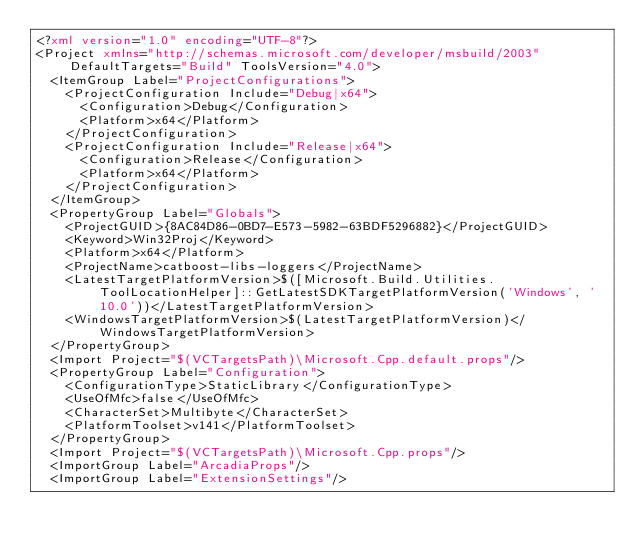Convert code to text. <code><loc_0><loc_0><loc_500><loc_500><_XML_><?xml version="1.0" encoding="UTF-8"?>
<Project xmlns="http://schemas.microsoft.com/developer/msbuild/2003" DefaultTargets="Build" ToolsVersion="4.0">
  <ItemGroup Label="ProjectConfigurations">
    <ProjectConfiguration Include="Debug|x64">
      <Configuration>Debug</Configuration>
      <Platform>x64</Platform>
    </ProjectConfiguration>
    <ProjectConfiguration Include="Release|x64">
      <Configuration>Release</Configuration>
      <Platform>x64</Platform>
    </ProjectConfiguration>
  </ItemGroup>
  <PropertyGroup Label="Globals">
    <ProjectGUID>{8AC84D86-0BD7-E573-5982-63BDF5296882}</ProjectGUID>
    <Keyword>Win32Proj</Keyword>
    <Platform>x64</Platform>
    <ProjectName>catboost-libs-loggers</ProjectName>
    <LatestTargetPlatformVersion>$([Microsoft.Build.Utilities.ToolLocationHelper]::GetLatestSDKTargetPlatformVersion('Windows', '10.0'))</LatestTargetPlatformVersion>
    <WindowsTargetPlatformVersion>$(LatestTargetPlatformVersion)</WindowsTargetPlatformVersion>
  </PropertyGroup>
  <Import Project="$(VCTargetsPath)\Microsoft.Cpp.default.props"/>
  <PropertyGroup Label="Configuration">
    <ConfigurationType>StaticLibrary</ConfigurationType>
    <UseOfMfc>false</UseOfMfc>
    <CharacterSet>Multibyte</CharacterSet>
    <PlatformToolset>v141</PlatformToolset>
  </PropertyGroup>
  <Import Project="$(VCTargetsPath)\Microsoft.Cpp.props"/>
  <ImportGroup Label="ArcadiaProps"/>
  <ImportGroup Label="ExtensionSettings"/></code> 